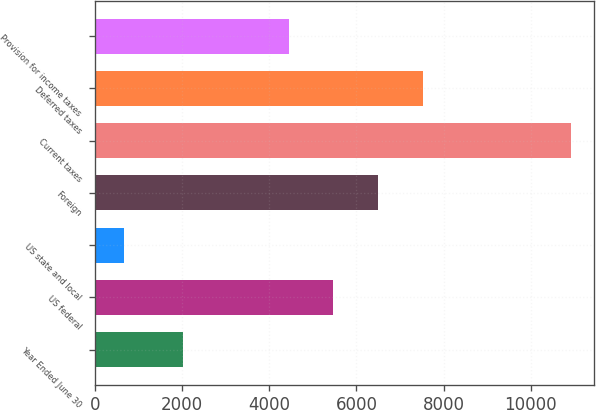Convert chart. <chart><loc_0><loc_0><loc_500><loc_500><bar_chart><fcel>Year Ended June 30<fcel>US federal<fcel>US state and local<fcel>Foreign<fcel>Current taxes<fcel>Deferred taxes<fcel>Provision for income taxes<nl><fcel>2019<fcel>5472.9<fcel>662<fcel>6497.8<fcel>10911<fcel>7522.7<fcel>4448<nl></chart> 